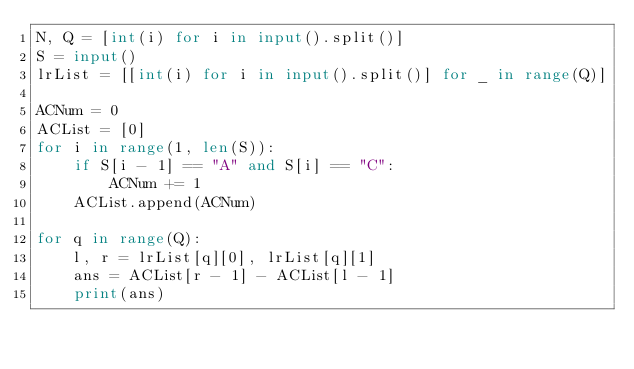<code> <loc_0><loc_0><loc_500><loc_500><_Python_>N, Q = [int(i) for i in input().split()]
S = input()
lrList = [[int(i) for i in input().split()] for _ in range(Q)]

ACNum = 0
ACList = [0]
for i in range(1, len(S)):
    if S[i - 1] == "A" and S[i] == "C":
        ACNum += 1
    ACList.append(ACNum)

for q in range(Q):
    l, r = lrList[q][0], lrList[q][1]
    ans = ACList[r - 1] - ACList[l - 1]
    print(ans)
</code> 